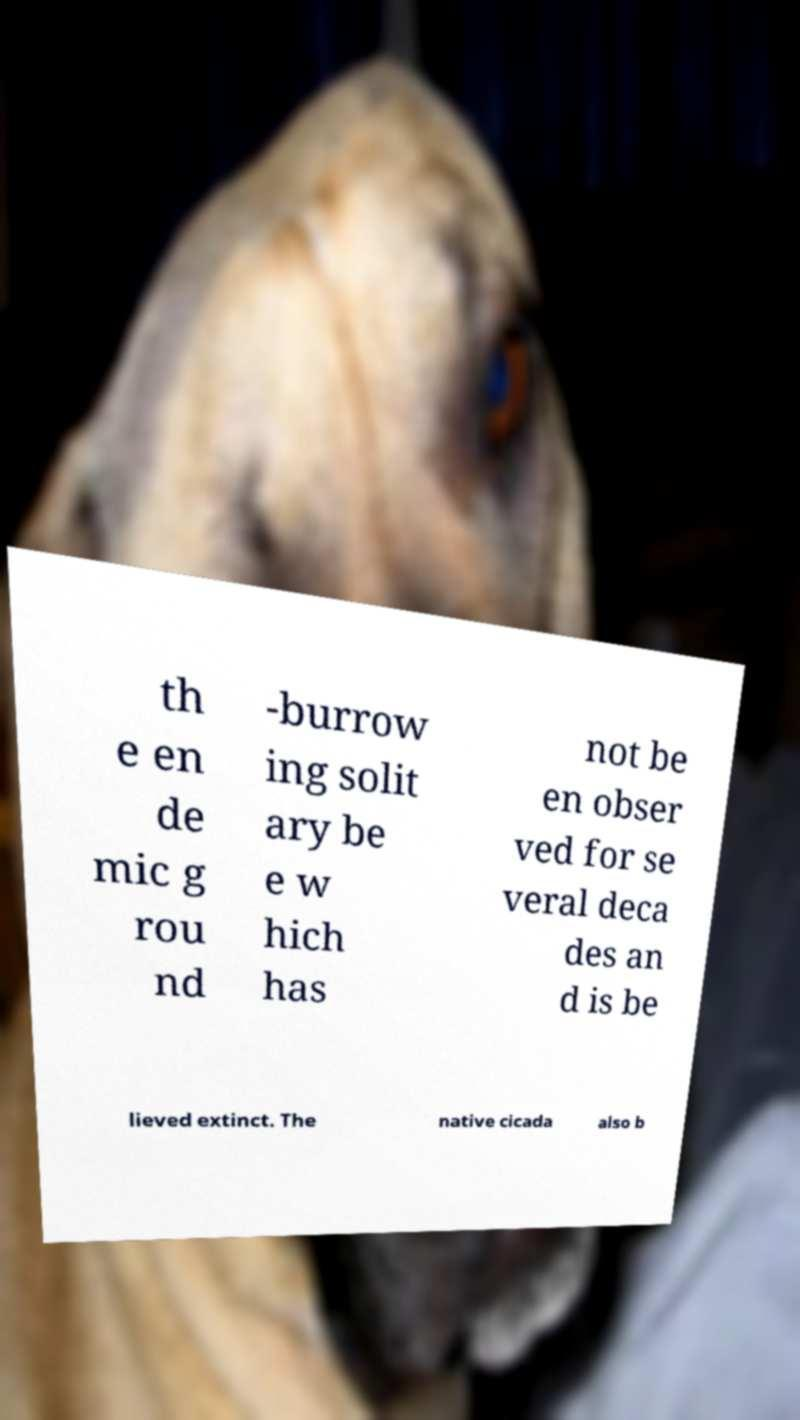What messages or text are displayed in this image? I need them in a readable, typed format. th e en de mic g rou nd -burrow ing solit ary be e w hich has not be en obser ved for se veral deca des an d is be lieved extinct. The native cicada also b 